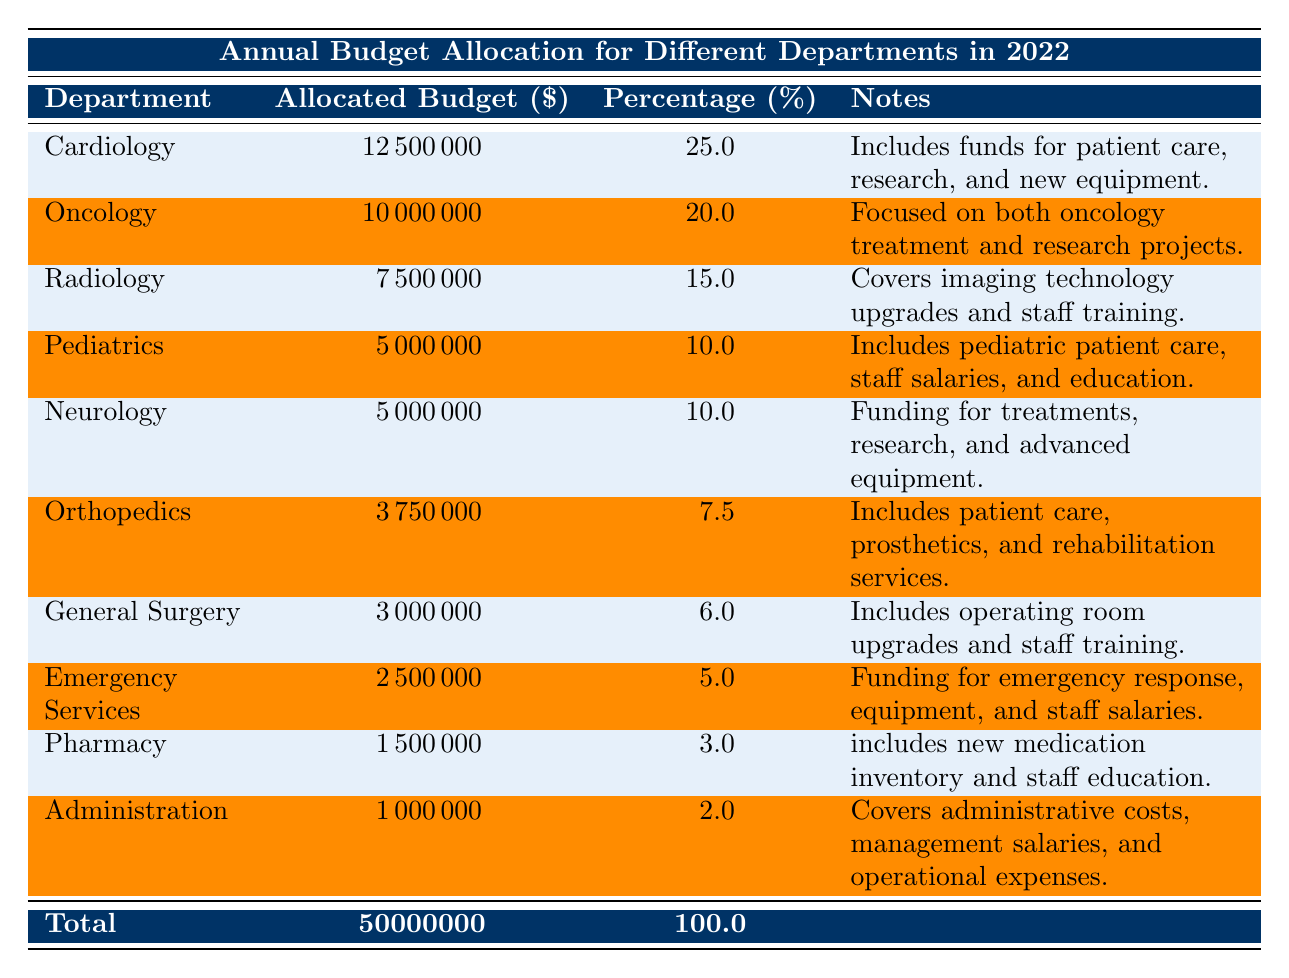What is the allocated budget for Cardiology? The table shows that the allocated budget for Cardiology is listed in the second column, and the specific value found there is 12500000.
Answer: 12500000 What percentage of the total budget is allocated to Oncology? Looking at the column for percentage, Oncology is listed with a value of 20.0 in the percentage column, indicating that it accounts for this portion of the total budget.
Answer: 20.0 Is the budget for Emergency Services greater than that for Pharmacy? By comparing the allocated budgets, Emergency Services has 2500000 while Pharmacy has 1500000. Since 2500000 is greater than 1500000, the statement is true.
Answer: Yes What is the total budget allocated to Pediatrics and Neurology combined? To find the total for Pediatrics and Neurology, we add their allocated budgets: 5000000 (Pediatrics) + 5000000 (Neurology) = 10000000.
Answer: 10000000 Which department has the lowest allocated budget, and what is that amount? Looking at the allocated budgets, Administration is listed with the lowest amount of 1000000, which is found in the first column corresponding to that department.
Answer: Administration, 1000000 What is the average allocated budget across all departments? The total budget is 50000000 for 10 departments. To find the average, we divide 50000000 by 10, which results in 5000000 as the average allocated budget per department.
Answer: 5000000 Is it true that more than half of the total budget is allocated to Cardiology and Oncology combined? First, we find the combined budget for Cardiology (12500000) and Oncology (10000000), which equals 22500000. Then, we check if this is more than half of the total budget (which is 25000000). Since 22500000 is less than 25000000, the statement is false.
Answer: No How much budget is allocated to Orthopedics compared to General Surgery? Checking the allocated budget, Orthopedics is given 3750000, while General Surgery is given 3000000. By noting that 3750000 is greater than 3000000, we can conclude that Orthopedics has more budget allocated than General Surgery.
Answer: Orthopedics has more budget How much more is allocated to Cardiology than to Radiology? To find the difference, we subtract the budget of Radiology (7500000) from that of Cardiology (12500000). This calculation results in 12500000 - 7500000 = 5000000, showing that Cardiology's budget is greater by this amount.
Answer: 5000000 